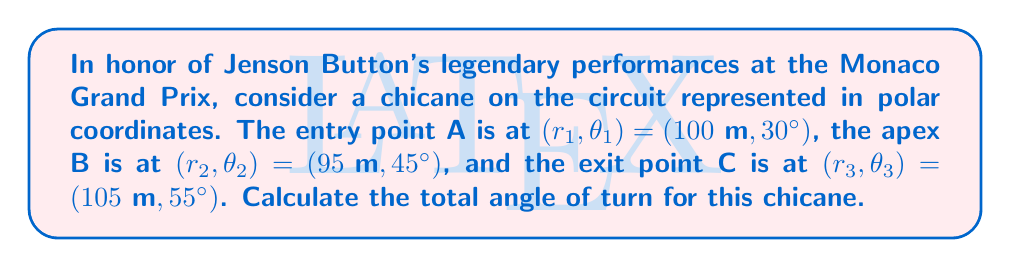Could you help me with this problem? To solve this problem, we need to calculate the angle between vectors OA and OC, where O is the origin. Here's a step-by-step approach:

1) First, let's convert the polar coordinates to Cartesian coordinates:

   A: $x_1 = r_1 \cos(\theta_1), y_1 = r_1 \sin(\theta_1)$
   C: $x_3 = r_3 \cos(\theta_3), y_3 = r_3 \sin(\theta_3)$

2) Calculate the coordinates:

   A: $x_1 = 100 \cos(30°) = 86.60\text{ m}, y_1 = 100 \sin(30°) = 50\text{ m}$
   C: $x_3 = 105 \cos(55°) = 60.21\text{ m}, y_3 = 105 \sin(55°) = 85.98\text{ m}$

3) The vectors OA and OC are:

   $\vec{OA} = (86.60, 50)$
   $\vec{OC} = (60.21, 85.98)$

4) The angle between these vectors can be calculated using the dot product formula:

   $$\cos(\alpha) = \frac{\vec{OA} \cdot \vec{OC}}{|\vec{OA}||\vec{OC}|}$$

5) Calculate the dot product:

   $\vec{OA} \cdot \vec{OC} = 86.60 \times 60.21 + 50 \times 85.98 = 9489.39$

6) Calculate the magnitudes:

   $|\vec{OA}| = \sqrt{86.60^2 + 50^2} = 100$
   $|\vec{OC}| = \sqrt{60.21^2 + 85.98^2} = 105$

7) Substitute into the formula:

   $$\cos(\alpha) = \frac{9489.39}{100 \times 105} = 0.9037$$

8) Take the inverse cosine (arccos) to find the angle:

   $$\alpha = \arccos(0.9037) = 25.00°$$

Therefore, the total angle of turn for this chicane is 25.00°.
Answer: 25.00° 